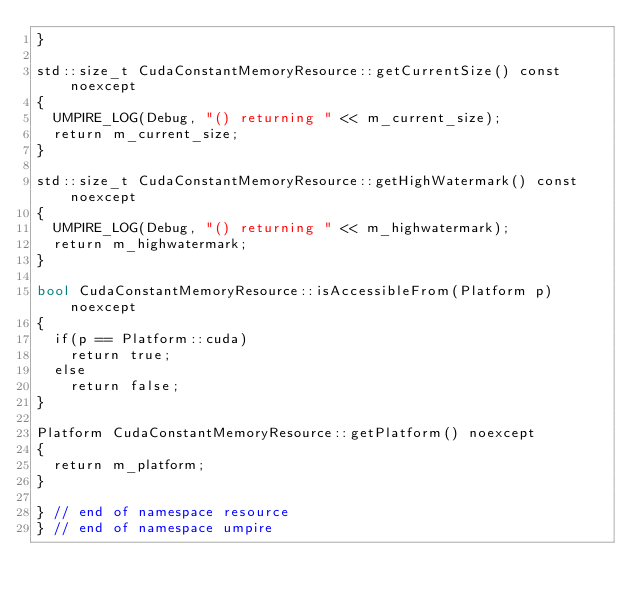<code> <loc_0><loc_0><loc_500><loc_500><_Cuda_>}

std::size_t CudaConstantMemoryResource::getCurrentSize() const noexcept
{
  UMPIRE_LOG(Debug, "() returning " << m_current_size);
  return m_current_size;
}

std::size_t CudaConstantMemoryResource::getHighWatermark() const noexcept
{
  UMPIRE_LOG(Debug, "() returning " << m_highwatermark);
  return m_highwatermark;
}

bool CudaConstantMemoryResource::isAccessibleFrom(Platform p) noexcept
{
  if(p == Platform::cuda)
    return true;
  else
    return false;
}

Platform CudaConstantMemoryResource::getPlatform() noexcept
{
  return m_platform;
}

} // end of namespace resource
} // end of namespace umpire
</code> 